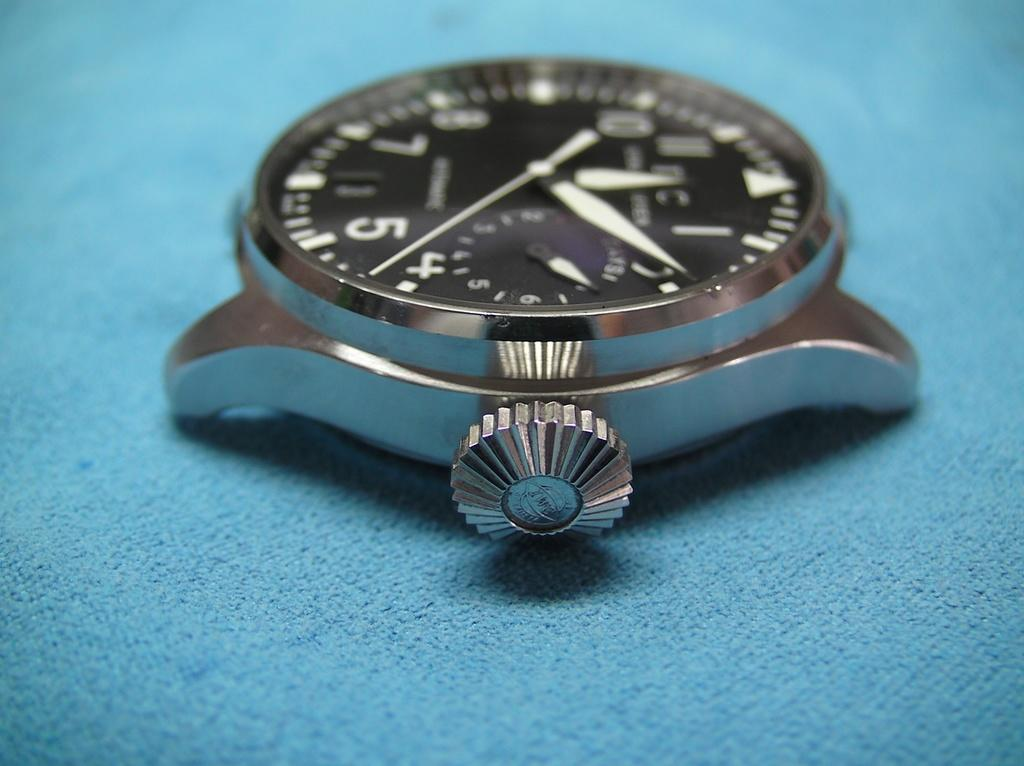<image>
Provide a brief description of the given image. A watch face sits on a blue surface, and it is approximately 12:09. 